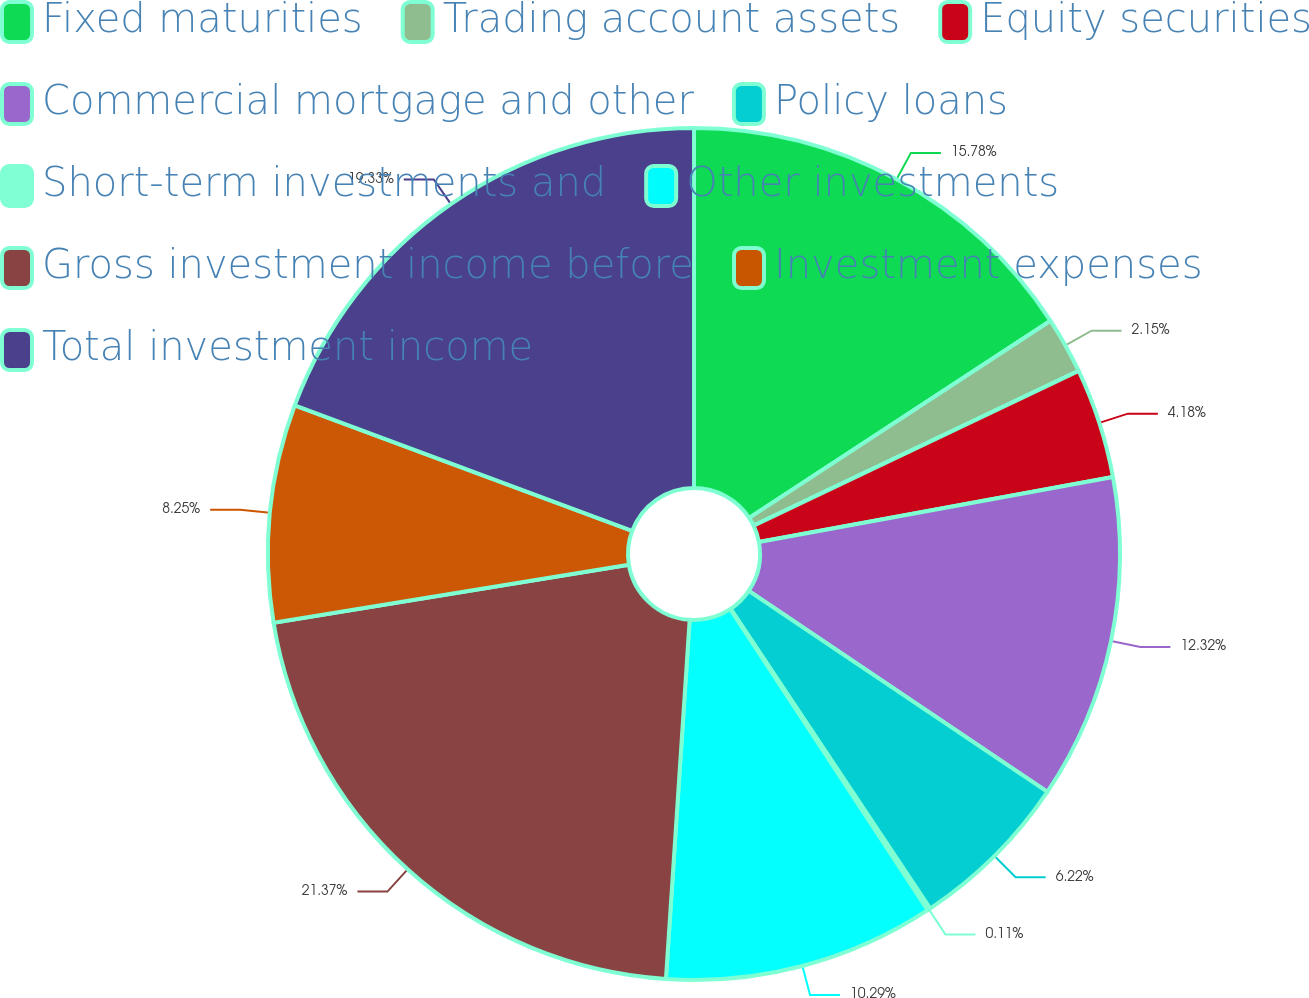<chart> <loc_0><loc_0><loc_500><loc_500><pie_chart><fcel>Fixed maturities<fcel>Trading account assets<fcel>Equity securities<fcel>Commercial mortgage and other<fcel>Policy loans<fcel>Short-term investments and<fcel>Other investments<fcel>Gross investment income before<fcel>Investment expenses<fcel>Total investment income<nl><fcel>15.78%<fcel>2.15%<fcel>4.18%<fcel>12.32%<fcel>6.22%<fcel>0.11%<fcel>10.29%<fcel>21.37%<fcel>8.25%<fcel>19.33%<nl></chart> 